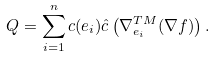<formula> <loc_0><loc_0><loc_500><loc_500>Q = \sum _ { i = 1 } ^ { n } c ( e _ { i } ) \hat { c } \left ( \nabla _ { e _ { i } } ^ { T M } ( \nabla f ) \right ) .</formula> 